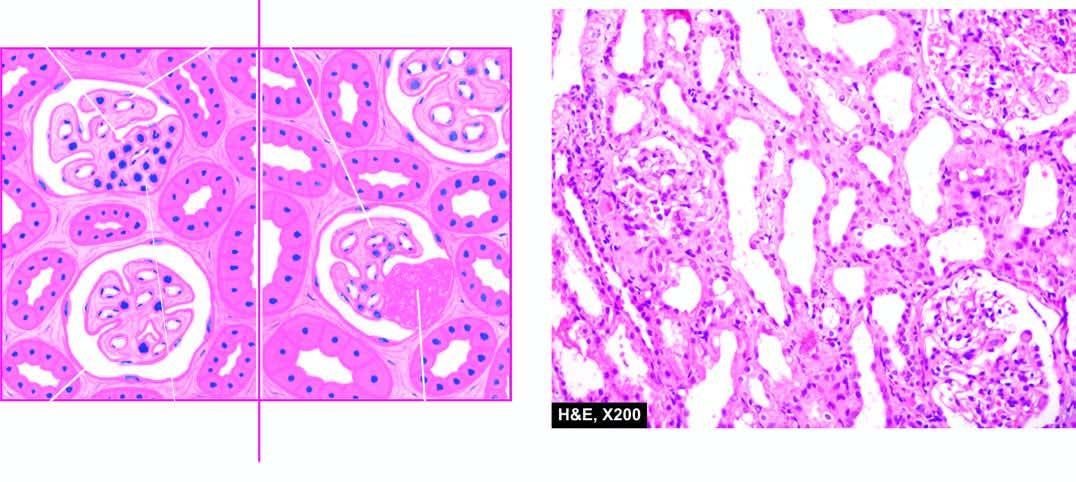re coal macules composed of aggregates of dust-laden macrophages and collagens focal and segmental involvement of the glomeruli by sclerosis and hyalinosis and mesangial hypercellularity?
Answer the question using a single word or phrase. No 